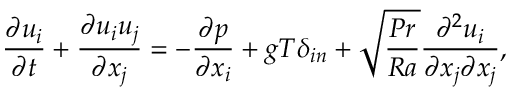<formula> <loc_0><loc_0><loc_500><loc_500>\frac { \partial u _ { i } } { \partial t } + \frac { \partial u _ { i } u _ { j } } { \partial x _ { j } } = - \frac { \partial p } { \partial x _ { i } } + g T \delta _ { i n } + \sqrt { \frac { P r } { R a } } \frac { \partial ^ { 2 } u _ { i } } { \partial x _ { j } \partial x _ { j } } ,</formula> 